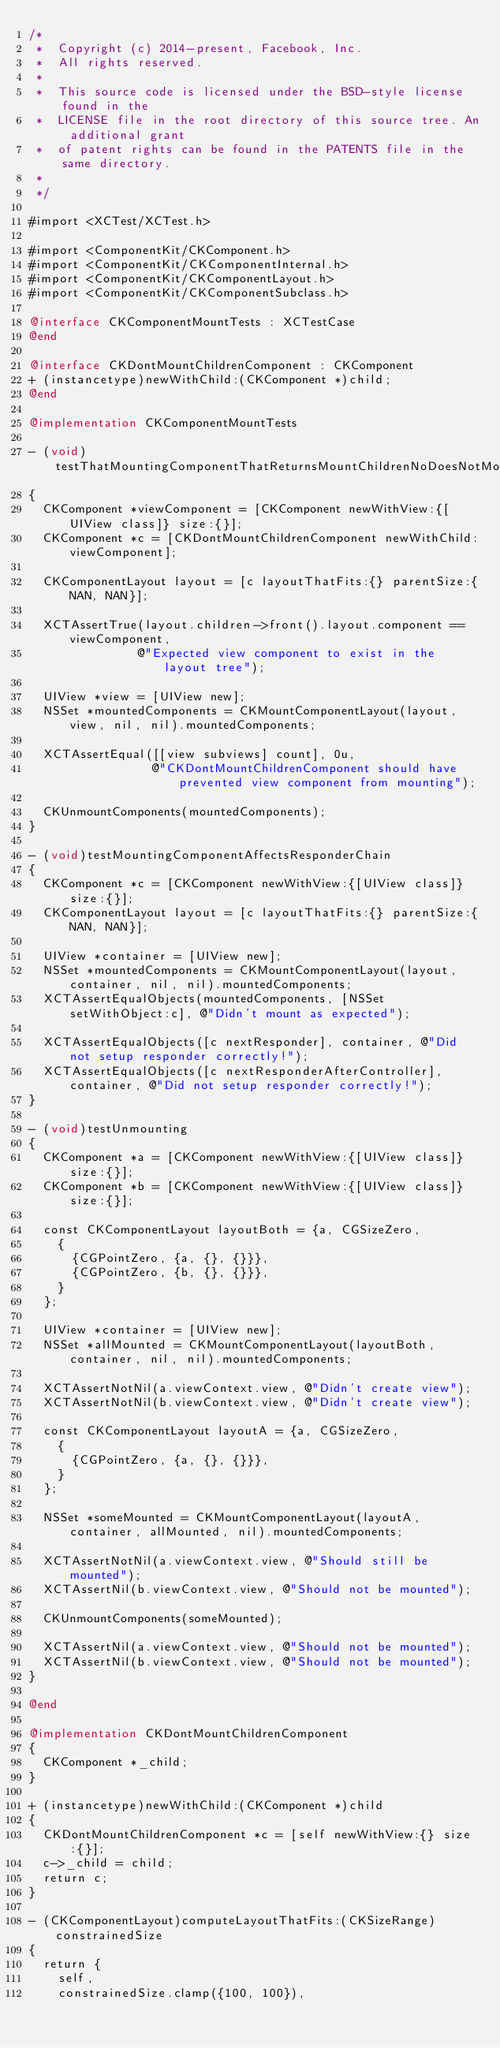<code> <loc_0><loc_0><loc_500><loc_500><_ObjectiveC_>/*
 *  Copyright (c) 2014-present, Facebook, Inc.
 *  All rights reserved.
 *
 *  This source code is licensed under the BSD-style license found in the
 *  LICENSE file in the root directory of this source tree. An additional grant
 *  of patent rights can be found in the PATENTS file in the same directory.
 *
 */

#import <XCTest/XCTest.h>

#import <ComponentKit/CKComponent.h>
#import <ComponentKit/CKComponentInternal.h>
#import <ComponentKit/CKComponentLayout.h>
#import <ComponentKit/CKComponentSubclass.h>

@interface CKComponentMountTests : XCTestCase
@end

@interface CKDontMountChildrenComponent : CKComponent
+ (instancetype)newWithChild:(CKComponent *)child;
@end

@implementation CKComponentMountTests

- (void)testThatMountingComponentThatReturnsMountChildrenNoDoesNotMountItsChild
{
  CKComponent *viewComponent = [CKComponent newWithView:{[UIView class]} size:{}];
  CKComponent *c = [CKDontMountChildrenComponent newWithChild:viewComponent];

  CKComponentLayout layout = [c layoutThatFits:{} parentSize:{NAN, NAN}];

  XCTAssertTrue(layout.children->front().layout.component == viewComponent,
               @"Expected view component to exist in the layout tree");

  UIView *view = [UIView new];
  NSSet *mountedComponents = CKMountComponentLayout(layout, view, nil, nil).mountedComponents;

  XCTAssertEqual([[view subviews] count], 0u,
                 @"CKDontMountChildrenComponent should have prevented view component from mounting");

  CKUnmountComponents(mountedComponents);
}

- (void)testMountingComponentAffectsResponderChain
{
  CKComponent *c = [CKComponent newWithView:{[UIView class]} size:{}];
  CKComponentLayout layout = [c layoutThatFits:{} parentSize:{NAN, NAN}];

  UIView *container = [UIView new];
  NSSet *mountedComponents = CKMountComponentLayout(layout, container, nil, nil).mountedComponents;
  XCTAssertEqualObjects(mountedComponents, [NSSet setWithObject:c], @"Didn't mount as expected");

  XCTAssertEqualObjects([c nextResponder], container, @"Did not setup responder correctly!");
  XCTAssertEqualObjects([c nextResponderAfterController], container, @"Did not setup responder correctly!");
}

- (void)testUnmounting
{
  CKComponent *a = [CKComponent newWithView:{[UIView class]} size:{}];
  CKComponent *b = [CKComponent newWithView:{[UIView class]} size:{}];

  const CKComponentLayout layoutBoth = {a, CGSizeZero,
    {
      {CGPointZero, {a, {}, {}}},
      {CGPointZero, {b, {}, {}}},
    }
  };

  UIView *container = [UIView new];
  NSSet *allMounted = CKMountComponentLayout(layoutBoth, container, nil, nil).mountedComponents;

  XCTAssertNotNil(a.viewContext.view, @"Didn't create view");
  XCTAssertNotNil(b.viewContext.view, @"Didn't create view");

  const CKComponentLayout layoutA = {a, CGSizeZero,
    {
      {CGPointZero, {a, {}, {}}},
    }
  };

  NSSet *someMounted = CKMountComponentLayout(layoutA, container, allMounted, nil).mountedComponents;

  XCTAssertNotNil(a.viewContext.view, @"Should still be mounted");
  XCTAssertNil(b.viewContext.view, @"Should not be mounted");

  CKUnmountComponents(someMounted);

  XCTAssertNil(a.viewContext.view, @"Should not be mounted");
  XCTAssertNil(b.viewContext.view, @"Should not be mounted");
}

@end

@implementation CKDontMountChildrenComponent
{
  CKComponent *_child;
}

+ (instancetype)newWithChild:(CKComponent *)child
{
  CKDontMountChildrenComponent *c = [self newWithView:{} size:{}];
  c->_child = child;
  return c;
}

- (CKComponentLayout)computeLayoutThatFits:(CKSizeRange)constrainedSize
{
  return {
    self,
    constrainedSize.clamp({100, 100}),</code> 